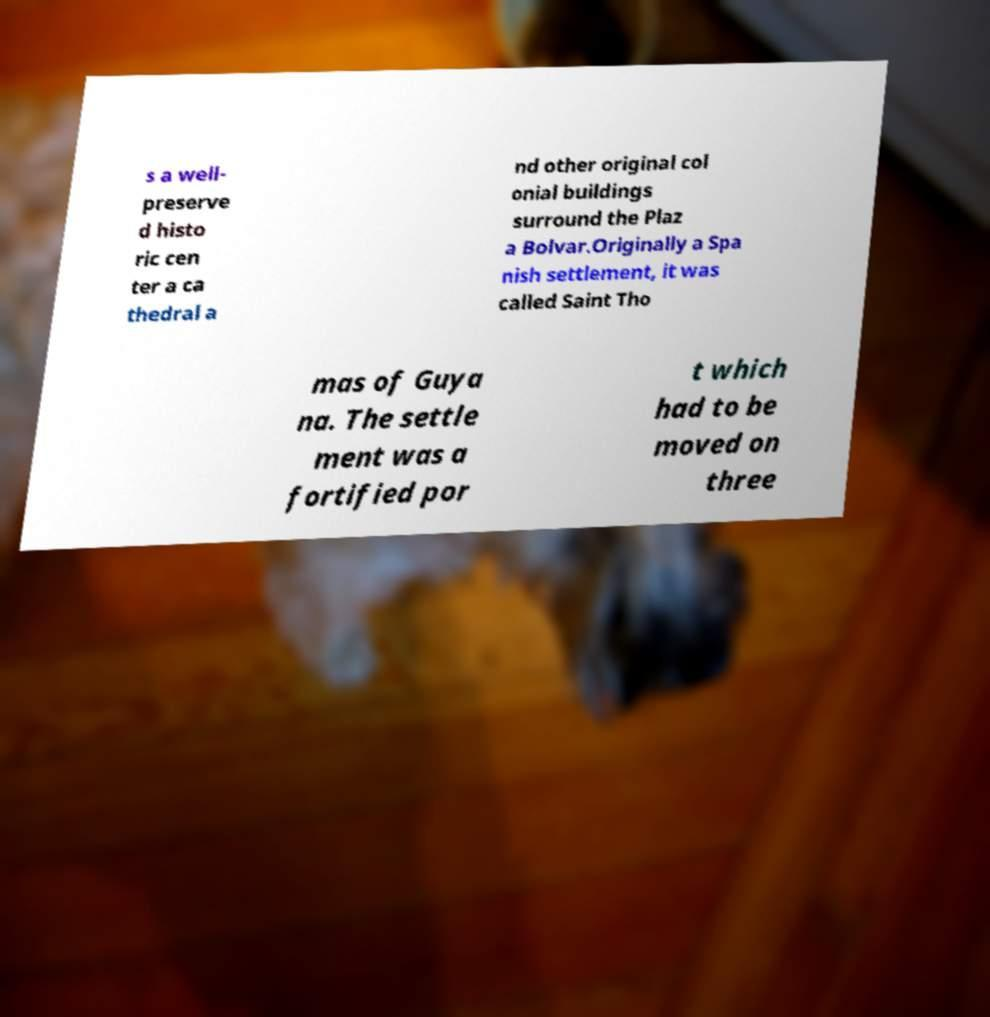Could you extract and type out the text from this image? s a well- preserve d histo ric cen ter a ca thedral a nd other original col onial buildings surround the Plaz a Bolvar.Originally a Spa nish settlement, it was called Saint Tho mas of Guya na. The settle ment was a fortified por t which had to be moved on three 